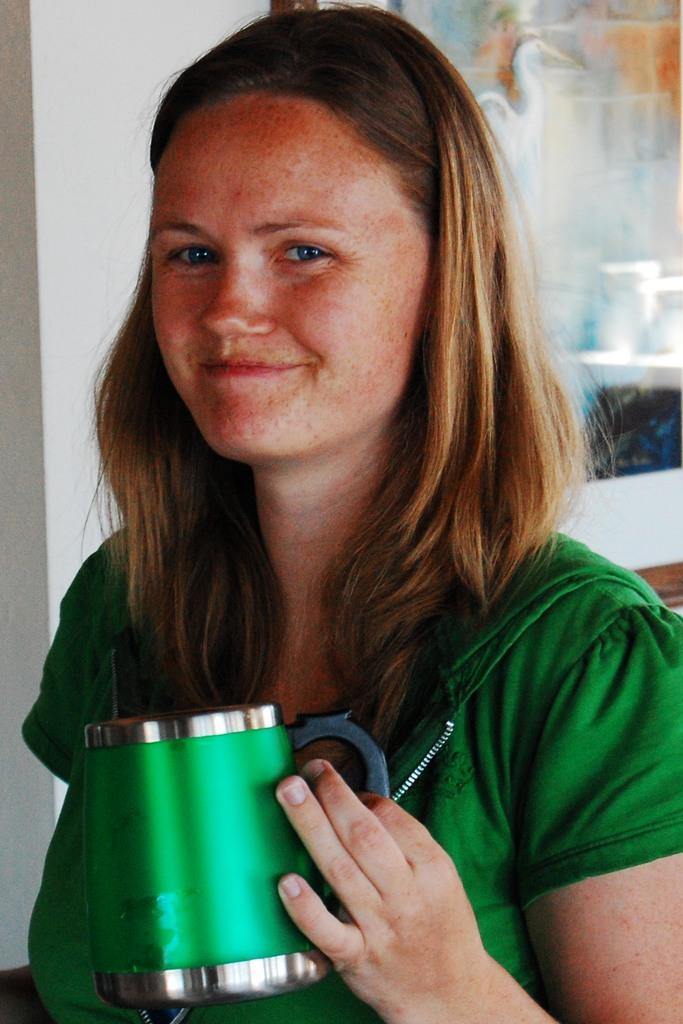Who is present in the image? There is a woman in the image. What is the woman holding in her hand? The woman is holding a cup in her hand. What is the woman's facial expression? The woman is smiling. What can be seen on the wall behind the woman? There is a poster attached to the wall behind the woman. What type of string is attached to the woman's pocket in the image? There is no string or pocket present on the woman in the image. 